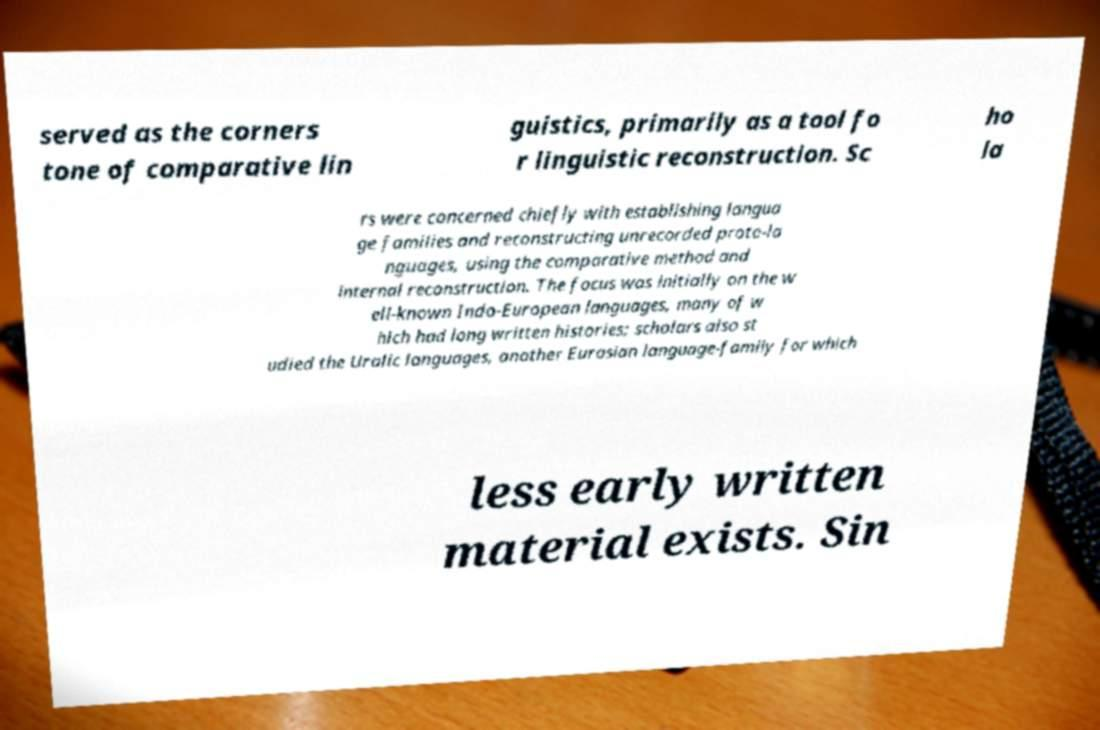Could you assist in decoding the text presented in this image and type it out clearly? served as the corners tone of comparative lin guistics, primarily as a tool fo r linguistic reconstruction. Sc ho la rs were concerned chiefly with establishing langua ge families and reconstructing unrecorded proto-la nguages, using the comparative method and internal reconstruction. The focus was initially on the w ell-known Indo-European languages, many of w hich had long written histories; scholars also st udied the Uralic languages, another Eurasian language-family for which less early written material exists. Sin 